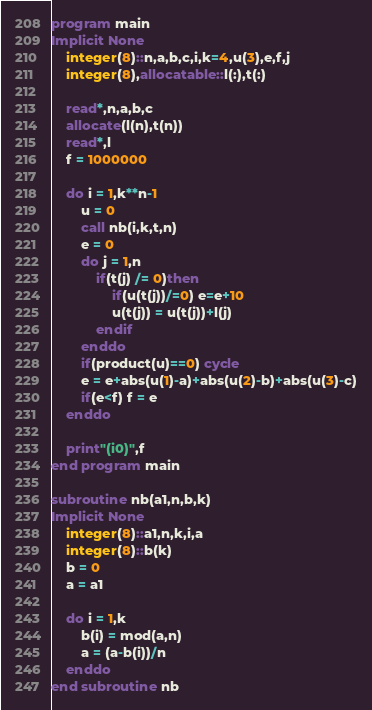Convert code to text. <code><loc_0><loc_0><loc_500><loc_500><_FORTRAN_>program main
Implicit None
	integer(8)::n,a,b,c,i,k=4,u(3),e,f,j
	integer(8),allocatable::l(:),t(:)
	
	read*,n,a,b,c
	allocate(l(n),t(n))
	read*,l
	f = 1000000
	
	do i = 1,k**n-1
		u = 0
		call nb(i,k,t,n)
		e = 0
		do j = 1,n
			if(t(j) /= 0)then
				if(u(t(j))/=0) e=e+10
				u(t(j)) = u(t(j))+l(j)
			endif
		enddo
		if(product(u)==0) cycle
		e = e+abs(u(1)-a)+abs(u(2)-b)+abs(u(3)-c)
		if(e<f) f = e
	enddo
	
	print"(i0)",f
end program main

subroutine nb(a1,n,b,k)
Implicit None
	integer(8)::a1,n,k,i,a
	integer(8)::b(k)
	b = 0
	a = a1
	
	do i = 1,k
		b(i) = mod(a,n)
		a = (a-b(i))/n
	enddo
end subroutine nb</code> 